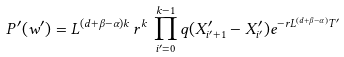Convert formula to latex. <formula><loc_0><loc_0><loc_500><loc_500>P ^ { \prime } ( w ^ { \prime } ) = L ^ { ( d + \beta - \alpha ) k } \, r ^ { k } \, \prod _ { i ^ { \prime } = 0 } ^ { k - 1 } q ( X _ { i ^ { \prime } + 1 } ^ { \prime } - X _ { i ^ { \prime } } ^ { \prime } ) e ^ { - r L ^ { ( d + \beta - \alpha ) } T ^ { \prime } }</formula> 